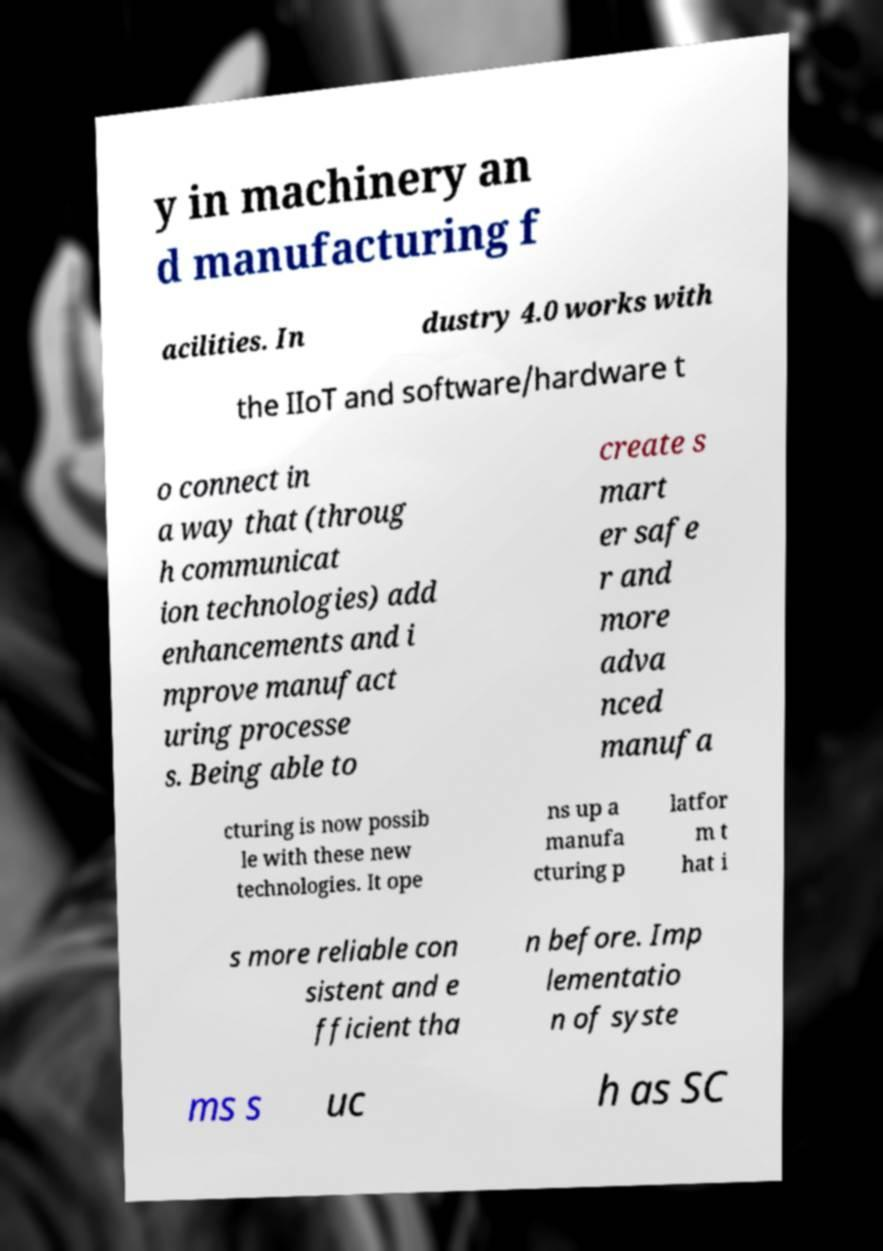I need the written content from this picture converted into text. Can you do that? y in machinery an d manufacturing f acilities. In dustry 4.0 works with the IIoT and software/hardware t o connect in a way that (throug h communicat ion technologies) add enhancements and i mprove manufact uring processe s. Being able to create s mart er safe r and more adva nced manufa cturing is now possib le with these new technologies. It ope ns up a manufa cturing p latfor m t hat i s more reliable con sistent and e fficient tha n before. Imp lementatio n of syste ms s uc h as SC 